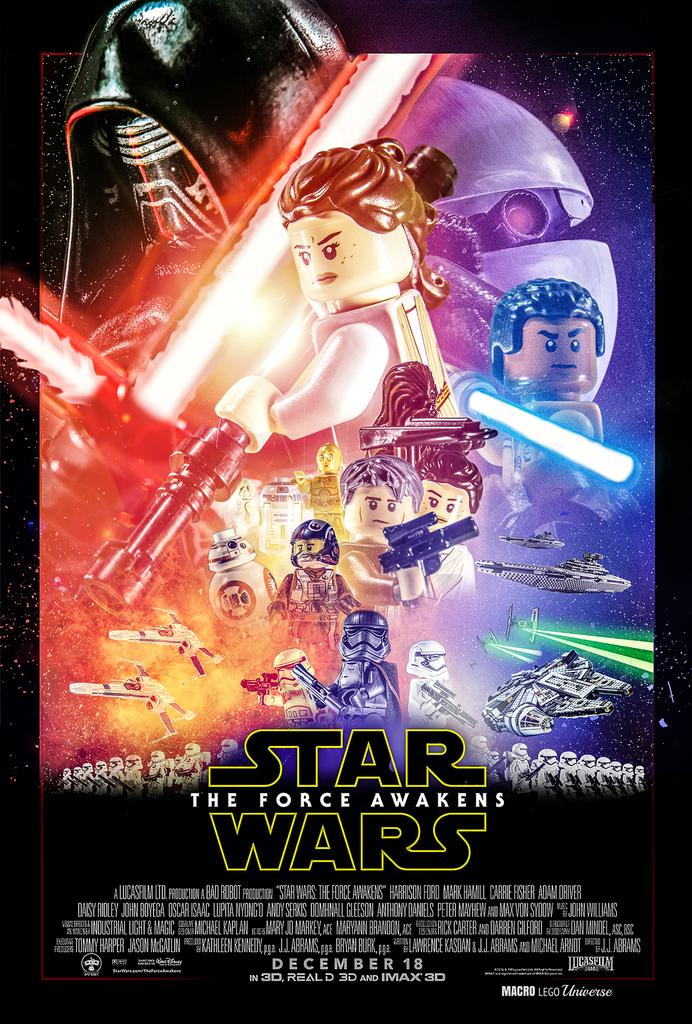<image>
Provide a brief description of the given image. Lego poster for Star Wars The Force Awakens. 